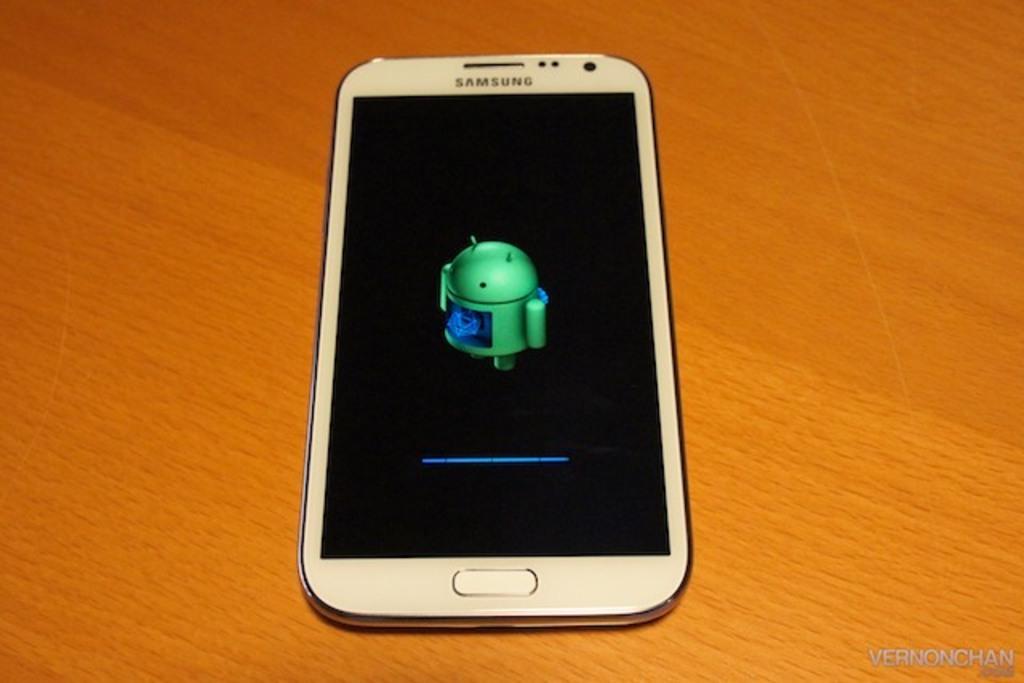What is the brand of the phone?
Your answer should be compact. Samsung. What is in the lower right corner?
Offer a terse response. Vernonchan. 